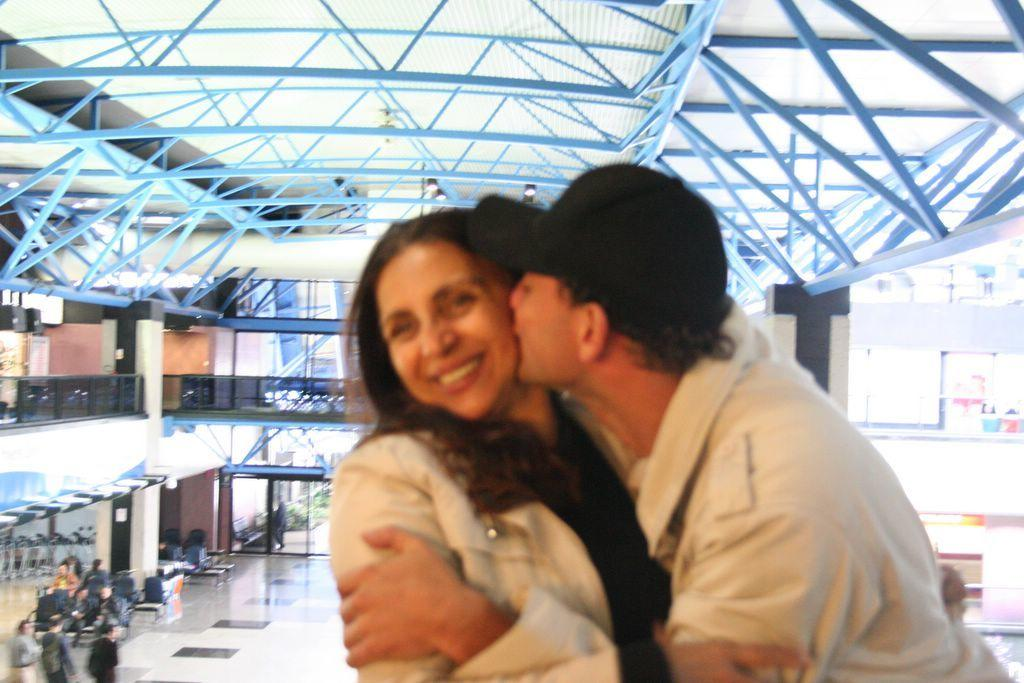Who is in the image? There is a man in the image. What is the man doing in the image? The man is kissing a woman on her cheek. What are the man and woman wearing? Both the man and the woman are wearing cream shirts. What can be seen at the bottom left of the image? There are people at the bottom left of the image. What architectural features are visible at the top of the image? There are rods and a roof at the top of the image. How many toads can be seen in the image? There are no toads present in the image. What type of class is being held in the image? There is no class being held in the image. 